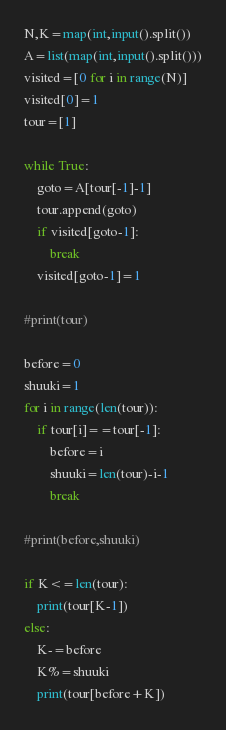Convert code to text. <code><loc_0><loc_0><loc_500><loc_500><_Python_>N,K=map(int,input().split())
A=list(map(int,input().split()))
visited=[0 for i in range(N)]
visited[0]=1
tour=[1]

while True:
    goto=A[tour[-1]-1]
    tour.append(goto)
    if visited[goto-1]:
        break
    visited[goto-1]=1

#print(tour)
    
before=0
shuuki=1
for i in range(len(tour)):
    if tour[i]==tour[-1]:
        before=i
        shuuki=len(tour)-i-1
        break

#print(before,shuuki)

if K<=len(tour):
    print(tour[K-1])
else:
    K-=before
    K%=shuuki
    print(tour[before+K])</code> 